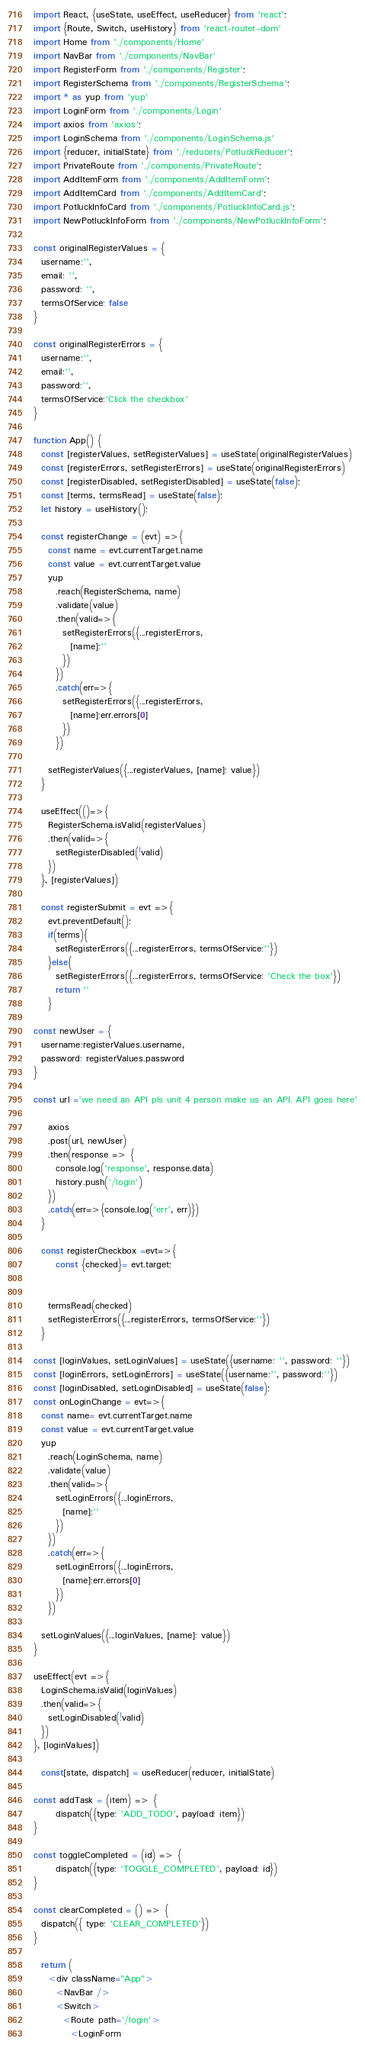Convert code to text. <code><loc_0><loc_0><loc_500><loc_500><_JavaScript_>import React, {useState, useEffect, useReducer} from 'react';
import {Route, Switch, useHistory} from 'react-router-dom'
import Home from './components/Home'
import NavBar from './components/NavBar'
import RegisterForm from './components/Register';
import RegisterSchema from './components/RegisterSchema';
import * as yup from 'yup'
import LoginForm from './components/Login'
import axios from 'axios';
import LoginSchema from './components/LoginSchema.js'
import {reducer, initialState} from './reducers/PotluckReducer';
import PrivateRoute from './components/PrivateRoute';
import AddItemForm from './components/AddItemForm';
import AddItemCard from './components/AddItemCard';
import PotluckInfoCard from './components/PotluckInfoCard.js';
import NewPotluckInfoForm from './components/NewPotluckInfoForm';

const originalRegisterValues = {
  username:'',
  email: '',
  password: '',
  termsOfService: false
}

const originalRegisterErrors = {
  username:'',
  email:'',
  password:'',
  termsOfService:'Click the checkbox'
}

function App() {
  const [registerValues, setRegisterValues] = useState(originalRegisterValues)
  const [registerErrors, setRegisterErrors] = useState(originalRegisterErrors)
  const [registerDisabled, setRegisterDisabled] = useState(false);
  const [terms, termsRead] = useState(false);
  let history = useHistory();
 
  const registerChange = (evt) =>{
    const name = evt.currentTarget.name
    const value = evt.currentTarget.value
    yup
      .reach(RegisterSchema, name)
      .validate(value)
      .then(valid=>{
        setRegisterErrors({...registerErrors,
          [name]:''
        })
      })
      .catch(err=>{
        setRegisterErrors({...registerErrors,
          [name]:err.errors[0]
        })
      })

    setRegisterValues({...registerValues, [name]: value})
  }

  useEffect(()=>{
    RegisterSchema.isValid(registerValues)
    .then(valid=>{
      setRegisterDisabled(!valid)
    })
  }, [registerValues])

  const registerSubmit = evt =>{
    evt.preventDefault();
    if(terms){
      setRegisterErrors({...registerErrors, termsOfService:''})
    }else{
      setRegisterErrors({...registerErrors, termsOfService: 'Check the box'})
      return ''
    }

const newUser = {
  username:registerValues.username,
  password: registerValues.password
}

const url ='we need an API pls unit 4 person make us an API. API goes here'

    axios
    .post(url, newUser)
    .then(response => {
      console.log('response', response.data)
      history.push('/login')
    })
    .catch(err=>{console.log('err', err)})
  }

  const registerCheckbox =evt=>{
      const {checked}= evt.target;

      
    termsRead(checked)
    setRegisterErrors({...registerErrors, termsOfService:''})
  }

const [loginValues, setLoginValues] = useState({username: '', password: ''})
const [loginErrors, setLoginErrors] = useState({username:'', password:''})
const [loginDisabled, setLoginDisabled] = useState(false);
const onLoginChange = evt=>{
  const name= evt.currentTarget.name
  const value = evt.currentTarget.value
  yup
    .reach(LoginSchema, name)
    .validate(value)
    .then(valid=>{
      setLoginErrors({...loginErrors,
        [name]:''
      })
    })
    .catch(err=>{
      setLoginErrors({...loginErrors,
        [name]:err.errors[0]
      })
    })

  setLoginValues({...loginValues, [name]: value})
}

useEffect(evt =>{
  LoginSchema.isValid(loginValues)
  .then(valid=>{
    setLoginDisabled(!valid)
  })
}, [loginValues])

  const[state, dispatch] = useReducer(reducer, initialState)
 
const addTask = (item) => {
      dispatch({type: 'ADD_TODO', payload: item})
}

const toggleCompleted = (id) => {
      dispatch({type: 'TOGGLE_COMPLETED', payload: id})
}

const clearCompleted = () => {
  dispatch({ type: 'CLEAR_COMPLETED'})
}

  return (
    <div className="App">
      <NavBar />
      <Switch>
        <Route path='/login'>
          <LoginForm</code> 